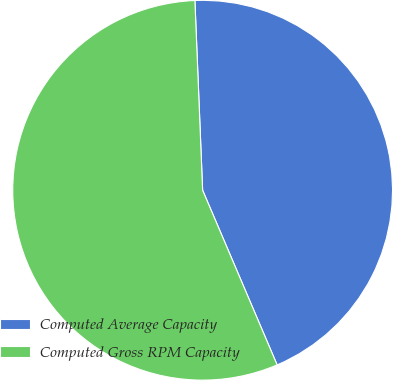Convert chart to OTSL. <chart><loc_0><loc_0><loc_500><loc_500><pie_chart><fcel>Computed Average Capacity<fcel>Computed Gross RPM Capacity<nl><fcel>44.23%<fcel>55.77%<nl></chart> 